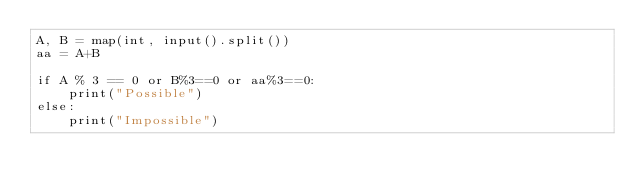<code> <loc_0><loc_0><loc_500><loc_500><_Python_>A, B = map(int, input().split())
aa = A+B

if A % 3 == 0 or B%3==0 or aa%3==0:
    print("Possible")
else:
    print("Impossible")</code> 